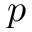<formula> <loc_0><loc_0><loc_500><loc_500>p</formula> 